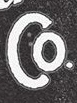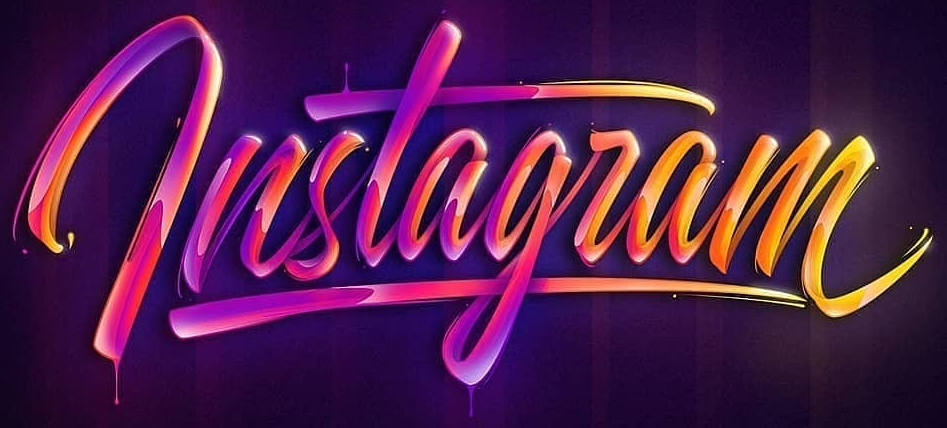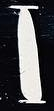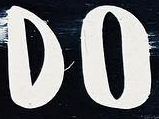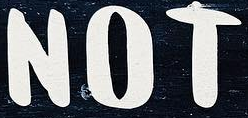What text is displayed in these images sequentially, separated by a semicolon? Co; lnstagram; I; DO; NOT 